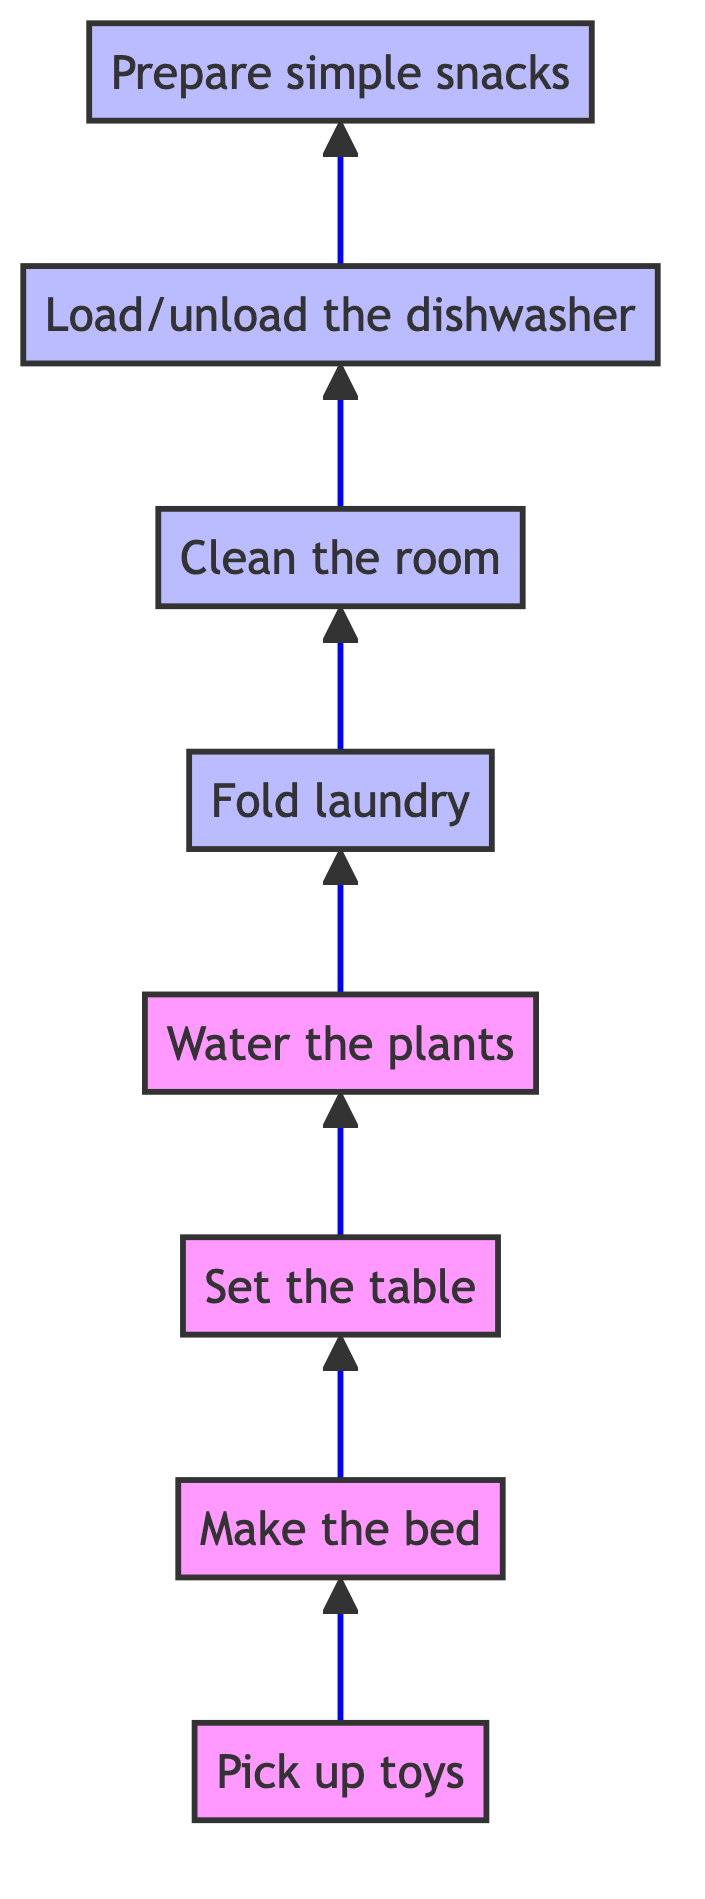What is the first task in the flow chart? The first task is "Pick up toys." This is the starting point at the bottom of the flow chart.
Answer: Pick up toys How many tasks are listed in the flow chart? Counting all the tasks from "Pick up toys" to "Prepare simple snacks," there are a total of eight tasks displayed in the diagram.
Answer: 8 Which task comes directly after "Make the bed"? The task that comes directly after "Make the bed" is "Set the table." This follows the arrow pointing upward in the diagram.
Answer: Set the table What is the last task in the flow chart? The last task, located at the top of the flow chart, is "Prepare simple snacks." This is the final action listed.
Answer: Prepare simple snacks Which tasks are considered complex according to the diagram's categorization? The tasks categorized as complex in the diagram are "Fold laundry," "Clean the room," "Load/unload the dishwasher," and "Prepare simple snacks." This is identified by their special styling in the flow chart.
Answer: Fold laundry, Clean the room, Load/unload the dishwasher, Prepare simple snacks How does "Water the plants" relate to "Set the table"? In the flow chart, "Water the plants" follows "Set the table," which means that to complete the task of watering plants, you must first complete the task of setting the table. This is determined by following the upward arrows connecting the tasks.
Answer: "Water the plants" follows "Set the table" What is the difference in task complexity between "Pick up toys" and "Prepare simple snacks"? "Pick up toys" is categorized as a basic task, while "Prepare simple snacks" is listed as a complex task. This indicates that "Prepare simple snacks" requires more effort or skill than simply picking up toys.
Answer: Complexity difference: basic vs complex How many 'complex' tasks are there in total? There are four tasks identified as complex in the flow chart: "Fold laundry," "Clean the room," "Load/unload the dishwasher," and "Prepare simple snacks." This is a count of all tasks that are marked as complex in the diagram.
Answer: 4 